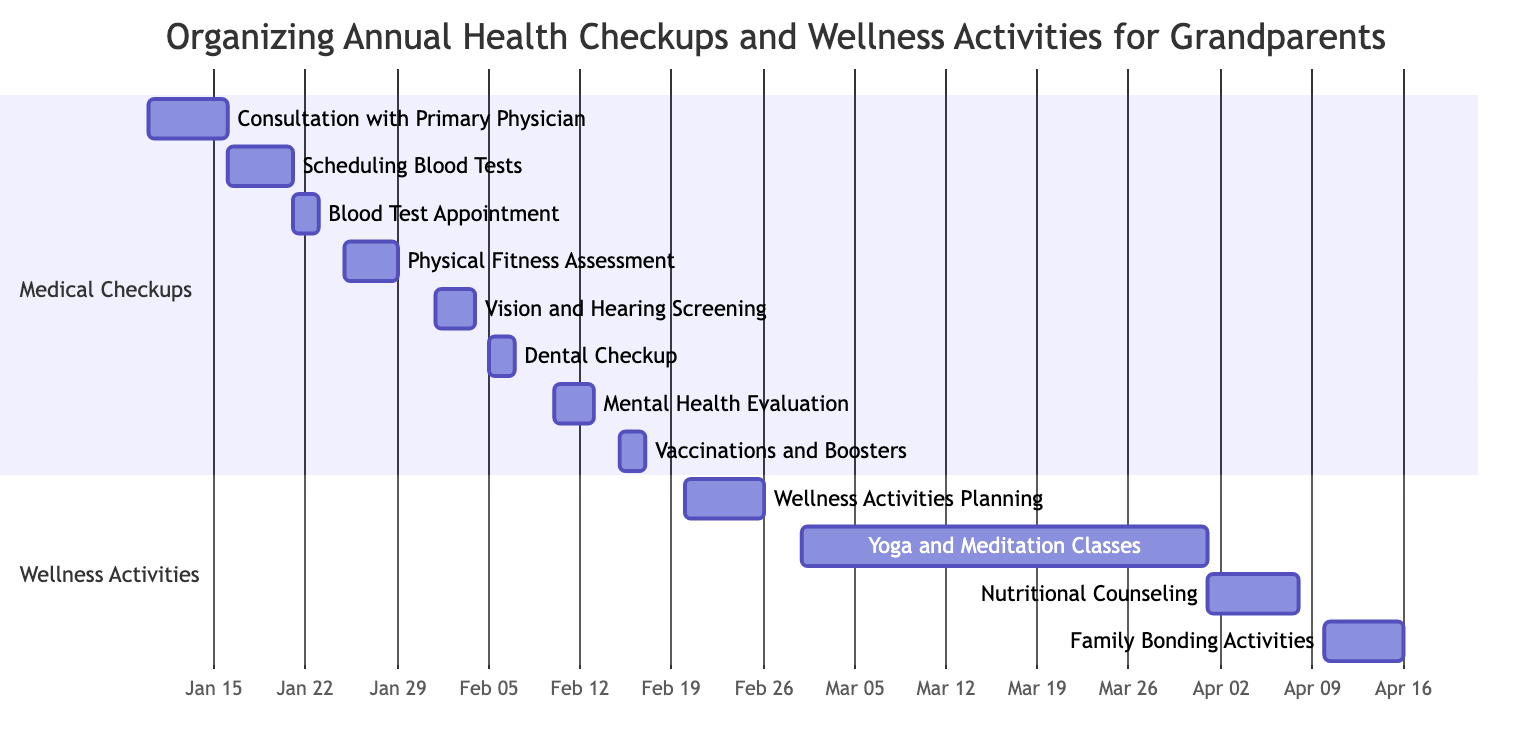What is the duration of the Physical Fitness Assessment? The Physical Fitness Assessment starts on January 25, 2023, and ends on January 28, 2023. Calculating the duration: January 28 - January 25 = 3 days
Answer: 4 days Which activity occurs right after the Dental Checkup? The Dental Checkup ends on February 6, 2023. The next activity listed, the Mental Health Evaluation, starts on February 10, 2023. Therefore, the Mental Health Evaluation follows the Dental Checkup
Answer: Mental Health Evaluation How many activities are planned in the Medical Checkups section? The Medical Checkups section lists a total of eight activities: Consultation with Primary Physician, Scheduling Blood Tests, Blood Test Appointment, Physical Fitness Assessment, Vision and Hearing Screening, Dental Checkup, Mental Health Evaluation, and Vaccinations and Boosters. Counting them gives us 8 activities
Answer: 8 What is the start date of the Yoga and Meditation Classes? The Yoga and Meditation Classes start on March 1, 2023, as indicated in the section for Wellness Activities. This is clearly depicted in the Gantt chart timeline
Answer: March 1, 2023 Which activity lasts the longest in the Wellness Activities section? Reviewing the activities in the Wellness Activities section: Wellness Activities Planning lasts for 6 days, Yoga and Meditation Classes lasts for 31 days, Nutritional Counseling lasts for 7 days, and Family Bonding Activities lasts for 6 days. Comparing these durations shows that Yoga and Meditation Classes has the longest duration
Answer: Yoga and Meditation Classes What is the end date of the vaccinations and boosters? The vaccinations and boosters activity starts on February 15, 2023, and ends on February 16, 2023, as per the timeline in the Gantt chart. Thus, the end date for this activity is February 16
Answer: February 16, 2023 How many days are there between the end of the Blood Test Appointment and the start of the Physical Fitness Assessment? The Blood Test Appointment ends on January 22, 2023, and the Physical Fitness Assessment begins on January 25, 2023. The gap can be calculated as follows: January 25 - January 22 = 3 days
Answer: 3 days In which month does the Family Bonding Activities occur? The Family Bonding Activities start on April 10, 2023, and end on April 15, 2023. This indicates that the activity takes place in the month of April, as clearly outlined in the schedule
Answer: April 